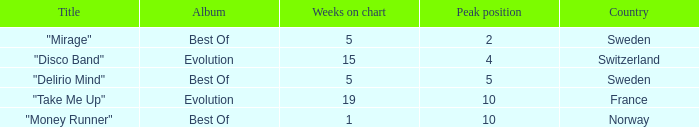What is the most weeks on chart when the peak position is less than 5 and from sweden? 5.0. 